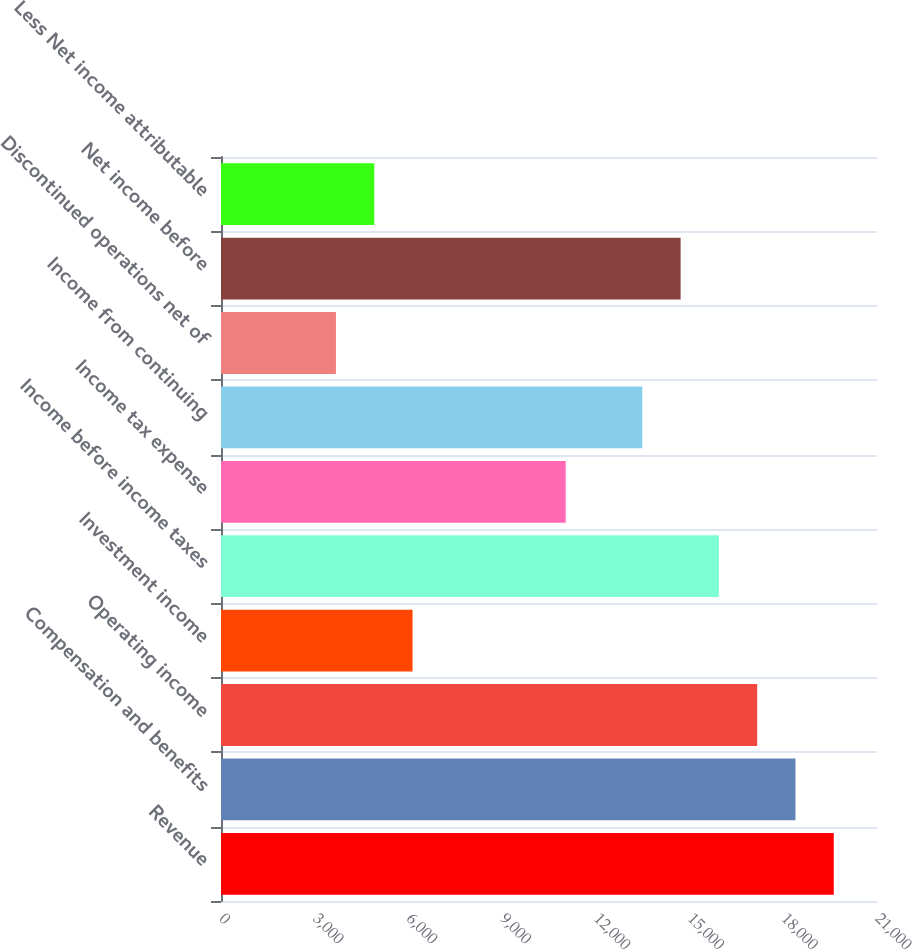<chart> <loc_0><loc_0><loc_500><loc_500><bar_chart><fcel>Revenue<fcel>Compensation and benefits<fcel>Operating income<fcel>Investment income<fcel>Income before income taxes<fcel>Income tax expense<fcel>Income from continuing<fcel>Discontinued operations net of<fcel>Net income before<fcel>Less Net income attributable<nl><fcel>19616.2<fcel>18390.3<fcel>17164.5<fcel>6131.72<fcel>15938.6<fcel>11035.2<fcel>13486.9<fcel>3680<fcel>14712.7<fcel>4905.86<nl></chart> 